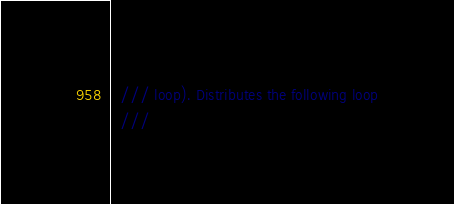<code> <loc_0><loc_0><loc_500><loc_500><_C_>  /// loop). Distributes the following loop
  ///</code> 